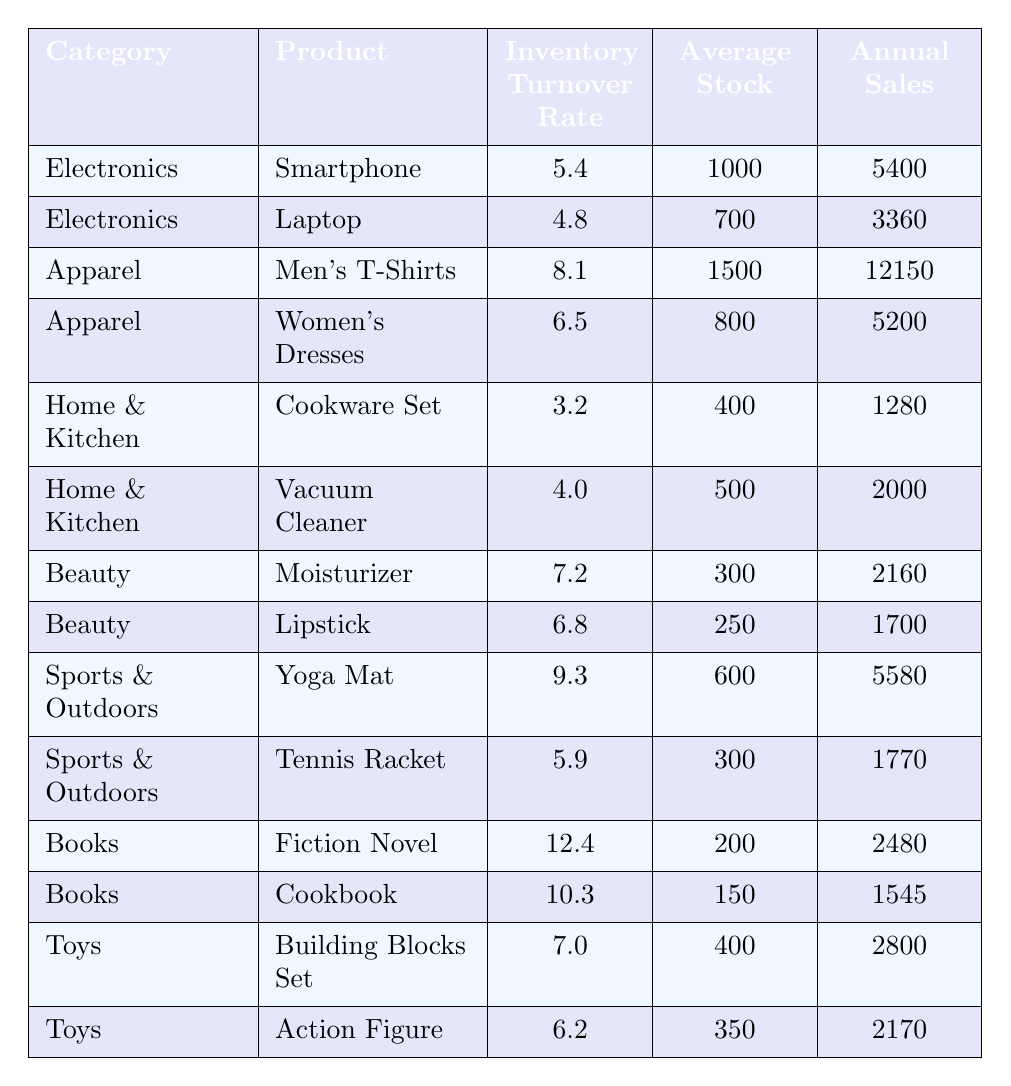What is the inventory turnover rate for Smartphones? The table lists the inventory turnover rate for Smartphones under the Electronics category, which is given as 5.4.
Answer: 5.4 Which product has the highest inventory turnover rate in the Toys category? In the Toys category, the inventory turnover rates for the products are 7.0 for Building Blocks Set and 6.2 for Action Figure. Comparing these rates, the Building Blocks Set has the highest at 7.0.
Answer: 7.0 What is the total annual sales for all products in the Beauty category? The annual sales for Moisturizer and Lipstick in the Beauty category are 2160 and 1700, respectively. Adding these values gives us 2160 + 1700 = 3860.
Answer: 3860 Which category has the lowest average inventory turnover rate? The Home & Kitchen category has inventory turnover rates of 3.2 for Cookware Set and 4.0 for Vacuum Cleaner. The average of these two rates is (3.2 + 4.0) / 2 = 3.6, which is lower than the averages of other categories.
Answer: Home & Kitchen Is it true that all products in the Sports & Outdoors category have an inventory turnover rate greater than 5.0? The inventory turnover rates for Yoga Mat and Tennis Racket are 9.3 and 5.9, respectively. Both are greater than 5.0, confirming that the statement is true.
Answer: Yes What is the average inventory turnover rate across all products? To find the average, we first sum all inventory turnover rates: 5.4 + 4.8 + 8.1 + 6.5 + 3.2 + 4.0 + 7.2 + 6.8 + 9.3 + 5.9 + 12.4 + 10.3 + 7.0 + 6.2 = 79.5. There are 14 products, so the average is 79.5 / 14 ≈ 5.68.
Answer: 5.68 What is the product with the least annual sales in the Home & Kitchen category? The annual sales figures for Home & Kitchen products are 1280 for Cookware Set and 2000 for Vacuum Cleaner. The lowest figure is for Cookware Set at 1280.
Answer: Cookware Set Which product has the second highest inventory turnover rate overall? The highest inventory turnover rate is for Fiction Novel at 12.4, and the second highest is for Cookbook at 10.3.
Answer: Cookbook How many products have an inventory turnover rate lower than 5.0? Reviewing the table, the products with rates below 5.0 are Laptop (4.8), Cookware Set (3.2), and Vacuum Cleaner (4.0), making a total of 3 products.
Answer: 3 What is the difference in inventory turnover rates between Men's T-Shirts and Women's Dresses? The inventory turnover rate for Men's T-Shirts is 8.1 and for Women's Dresses is 6.5. The difference is calculated as 8.1 - 6.5 = 1.6.
Answer: 1.6 Is the average stock for products in the Books category greater than 200? For the Books category, the average stock is calculated as (200 + 150) / 2 = 175. Since 175 is less than 200, the statement is false.
Answer: No 